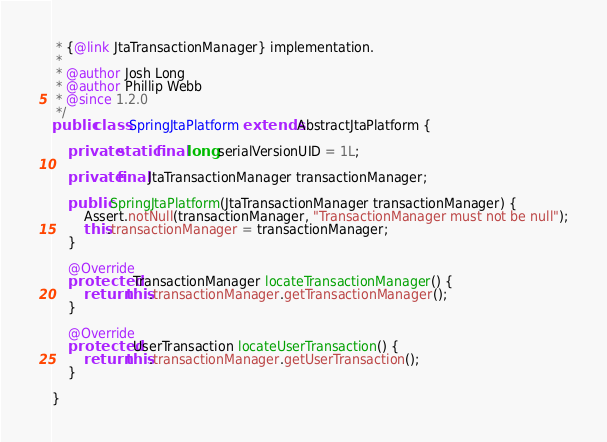<code> <loc_0><loc_0><loc_500><loc_500><_Java_> * {@link JtaTransactionManager} implementation.
 *
 * @author Josh Long
 * @author Phillip Webb
 * @since 1.2.0
 */
public class SpringJtaPlatform extends AbstractJtaPlatform {

	private static final long serialVersionUID = 1L;

	private final JtaTransactionManager transactionManager;

	public SpringJtaPlatform(JtaTransactionManager transactionManager) {
		Assert.notNull(transactionManager, "TransactionManager must not be null");
		this.transactionManager = transactionManager;
	}

	@Override
	protected TransactionManager locateTransactionManager() {
		return this.transactionManager.getTransactionManager();
	}

	@Override
	protected UserTransaction locateUserTransaction() {
		return this.transactionManager.getUserTransaction();
	}

}
</code> 